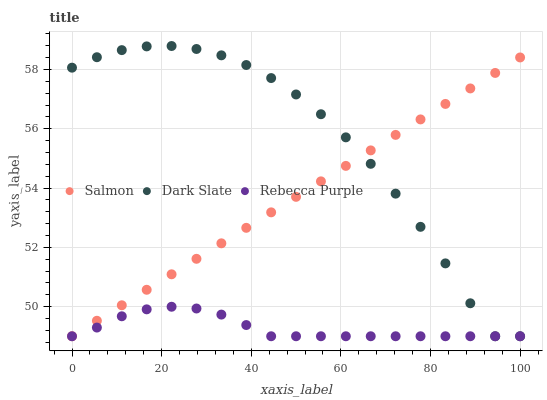Does Rebecca Purple have the minimum area under the curve?
Answer yes or no. Yes. Does Dark Slate have the maximum area under the curve?
Answer yes or no. Yes. Does Salmon have the minimum area under the curve?
Answer yes or no. No. Does Salmon have the maximum area under the curve?
Answer yes or no. No. Is Salmon the smoothest?
Answer yes or no. Yes. Is Dark Slate the roughest?
Answer yes or no. Yes. Is Rebecca Purple the smoothest?
Answer yes or no. No. Is Rebecca Purple the roughest?
Answer yes or no. No. Does Dark Slate have the lowest value?
Answer yes or no. Yes. Does Dark Slate have the highest value?
Answer yes or no. Yes. Does Salmon have the highest value?
Answer yes or no. No. Does Salmon intersect Rebecca Purple?
Answer yes or no. Yes. Is Salmon less than Rebecca Purple?
Answer yes or no. No. Is Salmon greater than Rebecca Purple?
Answer yes or no. No. 